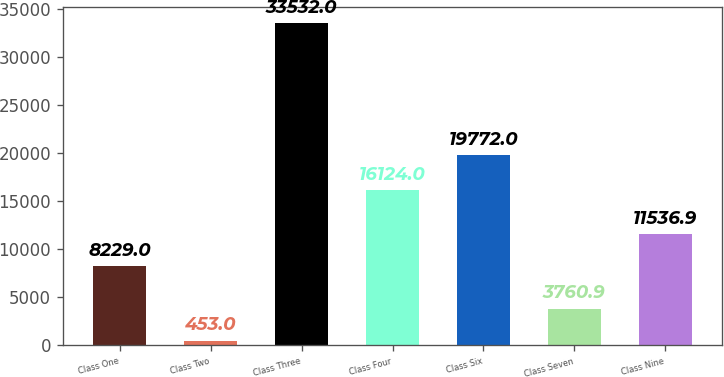Convert chart to OTSL. <chart><loc_0><loc_0><loc_500><loc_500><bar_chart><fcel>Class One<fcel>Class Two<fcel>Class Three<fcel>Class Four<fcel>Class Six<fcel>Class Seven<fcel>Class Nine<nl><fcel>8229<fcel>453<fcel>33532<fcel>16124<fcel>19772<fcel>3760.9<fcel>11536.9<nl></chart> 